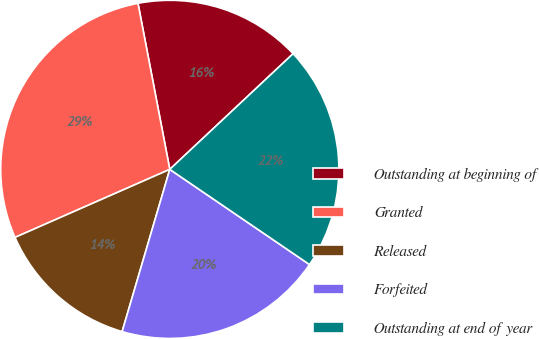Convert chart to OTSL. <chart><loc_0><loc_0><loc_500><loc_500><pie_chart><fcel>Outstanding at beginning of<fcel>Granted<fcel>Released<fcel>Forfeited<fcel>Outstanding at end of year<nl><fcel>16.02%<fcel>28.58%<fcel>13.86%<fcel>20.03%<fcel>21.51%<nl></chart> 